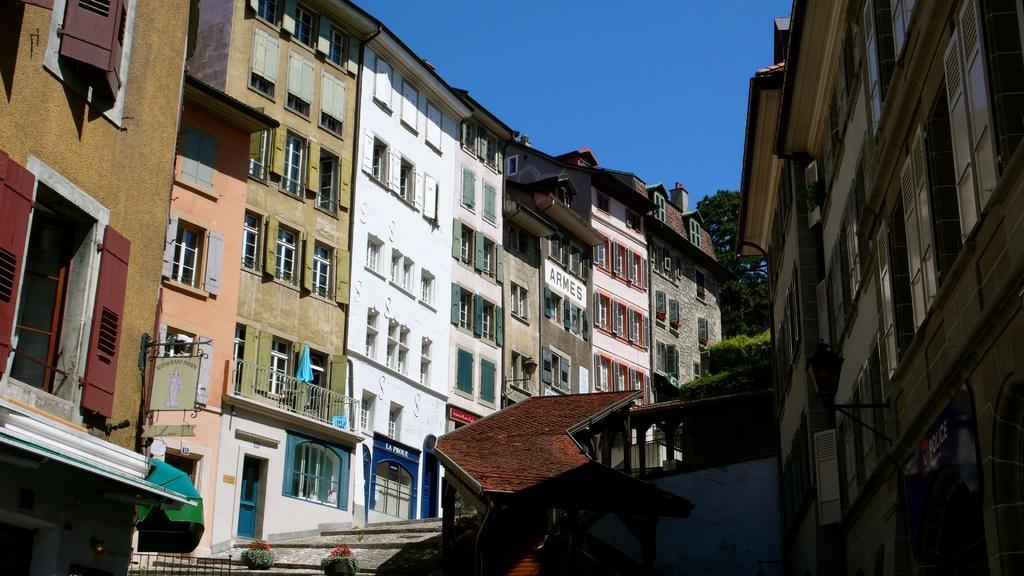Can you describe this image briefly? In this image we can see many buildings with windows, railing. On the building there are names. At the bottom there are pots with plants. In the back there are trees. In the background there is sky. 